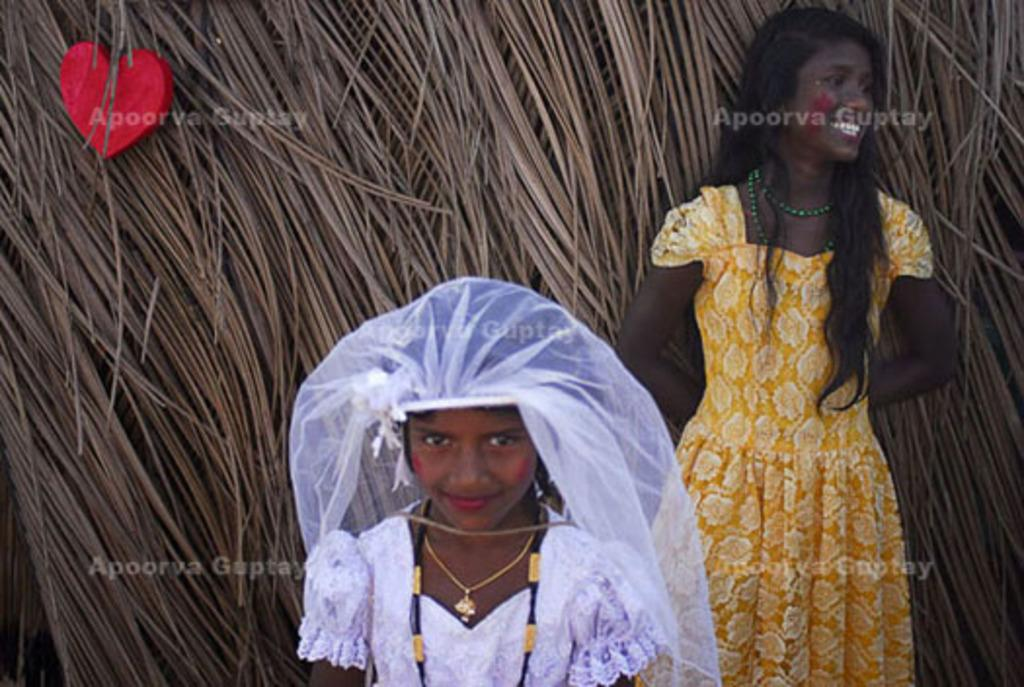How many people are present in the image? There are a few people in the image. What can be seen in the background of the image? There are dried coconut leaves in the background of the image. Is there anything else associated with the dried coconut leaves in the background? Yes, there is an object associated with the dried coconut leaves in the background. What type of jewel can be seen on the kitten in the image? There is no kitten or jewel present in the image. How many cars are visible in the image? There are no cars visible in the image. 